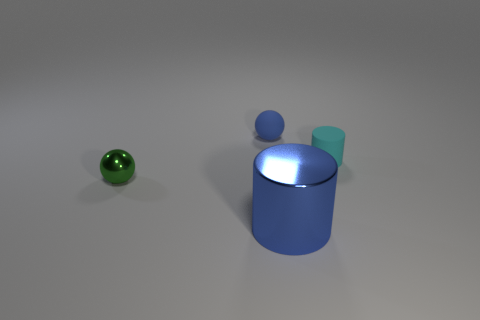Add 1 cyan rubber cylinders. How many objects exist? 5 Subtract all balls. Subtract all rubber things. How many objects are left? 0 Add 1 big blue shiny cylinders. How many big blue shiny cylinders are left? 2 Add 1 tiny cyan cylinders. How many tiny cyan cylinders exist? 2 Subtract 0 cyan balls. How many objects are left? 4 